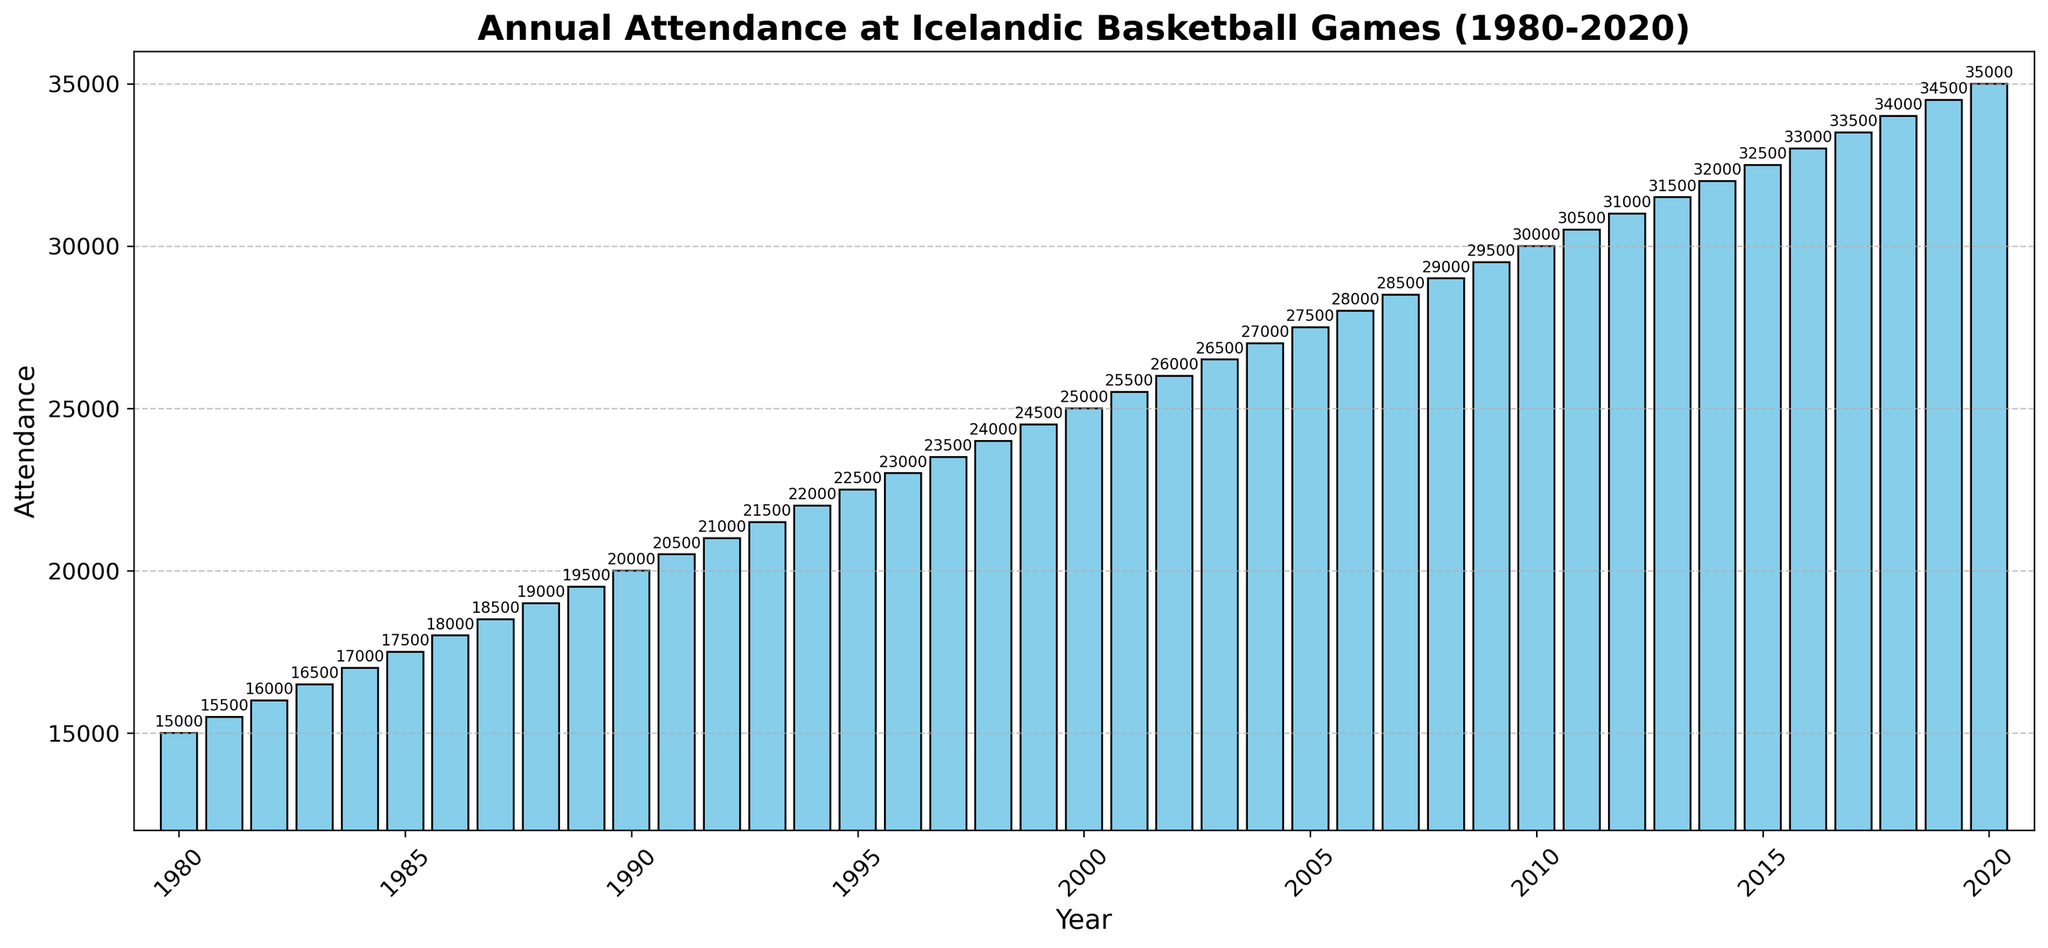Which year had the highest attendance? By visually inspecting the height of the bars in the chart, the one corresponding to 2020 is the tallest, indicating the highest attendance.
Answer: 2020 What was the total attendance from 1980 to 1990? Summing up the attendance values for the years 1980 to 1990: 15000 + 15500 + 16000 + 16500 + 17000 + 17500 + 18000 + 18500 + 19000 + 19500 + 20000 = 203000
Answer: 203000 Which year had more attendance: 1995 or 2000? By comparison, the bar in the year 2000 is taller than the bar in 1995, indicating higher attendance. Checking values confirms: 25000 (2000) > 22500 (1995).
Answer: 2000 Is the attendance growth uniform each year? By scanning the heights of the bars, the increase in attendance each year appears uniform, as the bars gradually get taller each consecutive year. Comparing the difference between consecutive years also supports this observation.
Answer: Yes What was the average attendance in the 1980s? First, we find the total attendance for the years 1980 to 1989: 15000 + 15500 + 16000 + 16500 + 17000 + 17500 + 18000 + 18500 + 19000 + 19500 = 177000. Then, we divide by 10 (number of years): 177000 / 10 = 17700
Answer: 17700 In which decade did the attendance grow the fastest? Looking at the differences in attendance between the start and end of each decade, the biggest increase occurs in the 2010s: 34500 (2019) - 30000 (2010) = 4500. Comparing this to other decades shows this is the highest growth.
Answer: 2010s How much did the attendance increase from 1980 to 2020? Subtract 1980 attendance (15000) from 2020 attendance (35000): 35000 - 15000 = 20000
Answer: 20000 What is the median value of the annual attendance? Since we have an even number of years (41), the median will be the average of the 20th and 21st values. Looking at the attendance values, they are: 24500 (1999) and 25000 (2000). Median = (24500 + 25000) / 2 = 24750
Answer: 24750 Which year had the first attendance value over 30000? By scanning the chart, the first bar that exceeds the 30000 mark is 2010. Verifying with the data confirms attendance for 2010 is exactly 30000.
Answer: 2010 